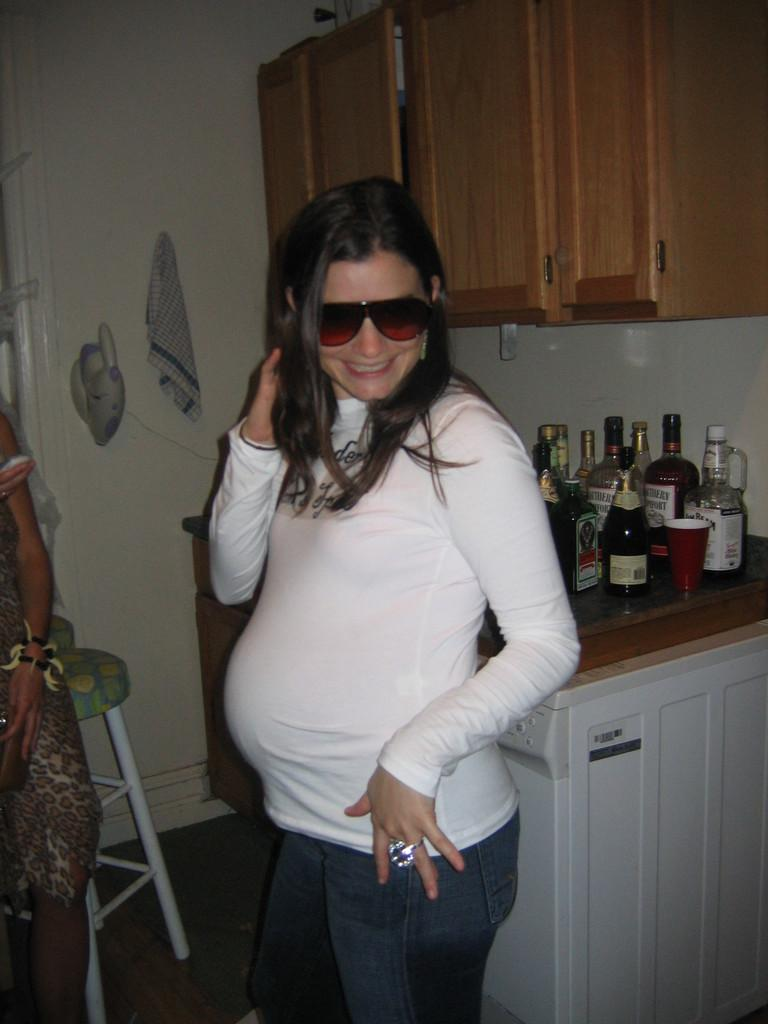How many people are in the image? There are two persons standing in the image. Where is the image taken? The image appears to be taken in a room. What objects can be seen in the background of the image? There is a stool, a cabinet, a wall, bottles, cups, and shelves in the background of the image. What type of force is being applied to the substance in the image? There is no substance or force present in the image; it features two persons standing in a room with various objects in the background. 